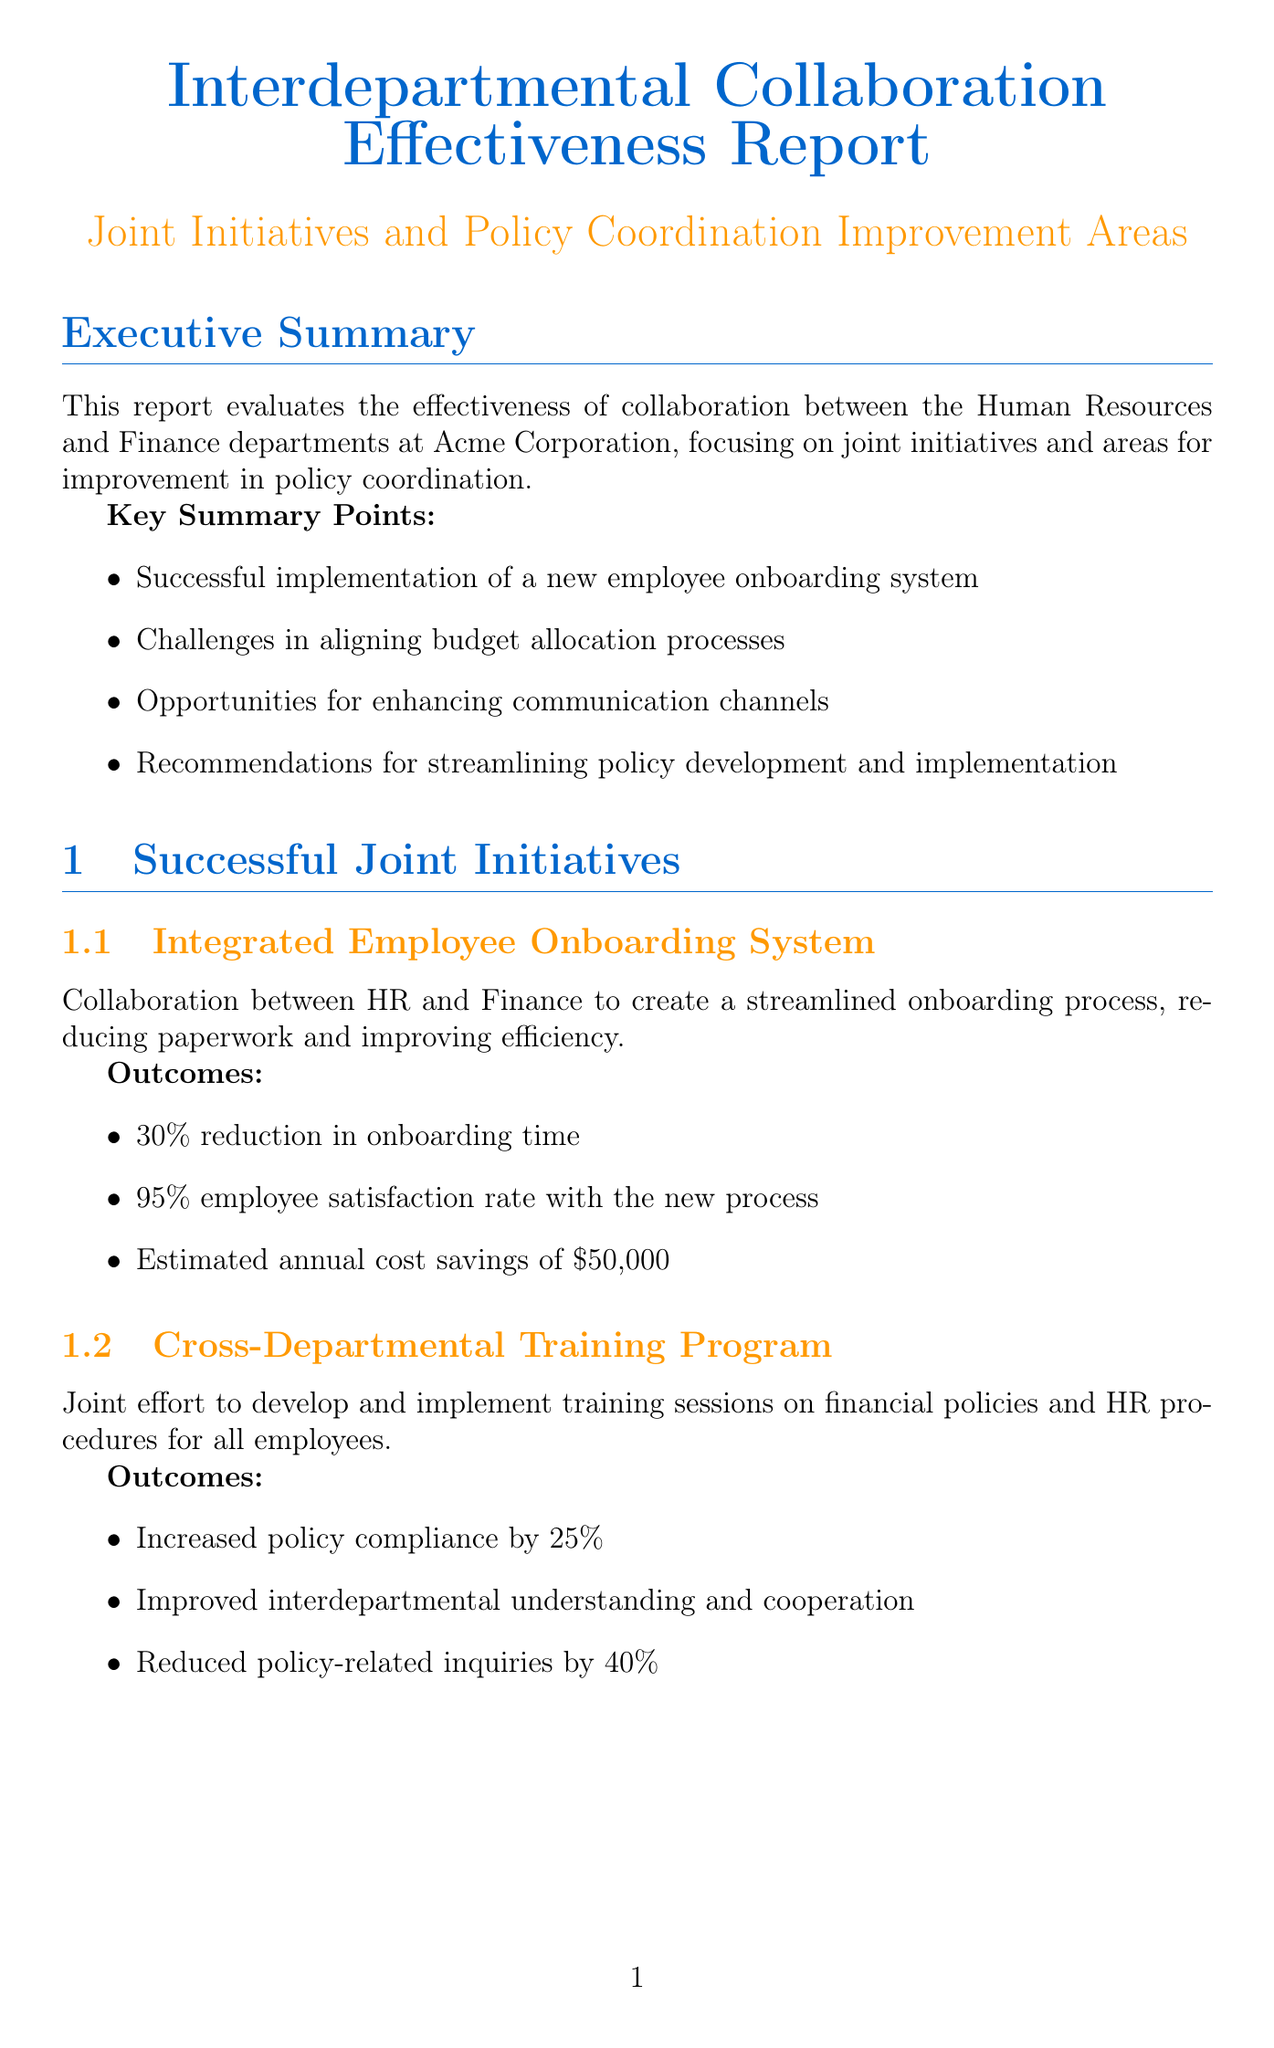What are the key departments evaluated in the report? The report evaluates the collaboration between the Human Resources and Finance departments.
Answer: Human Resources and Finance What is the percentage of improvement in policy compliance from the training program? The Cross-Departmental Training Program led to a 25% increase in policy compliance.
Answer: 25% What is the current value of the Joint Initiative Success Rate? The current value for the Joint Initiative Success Rate is 65%.
Answer: 65% What are the estimated annual cost savings from the Integrated Employee Onboarding System? The Integrated Employee Onboarding System results in estimated annual cost savings of $50,000.
Answer: $50,000 What is one recommended action for improving the budget allocation process? One recommended action is to establish quarterly joint budget review meetings.
Answer: Establish quarterly joint budget review meetings What is the proposed timeline for establishing the joint policy review committee? The priority action intends to establish the joint policy review committee within the next 30 days.
Answer: Within the next 30 days What is the target value for Policy Implementation Time? The target value for Policy Implementation Time is 30 days.
Answer: 30 days What percentage of action items are successfully completed after joint meetings? Currently, 70% of action items are successfully completed following joint meetings.
Answer: 70% What platform is proposed for real-time interdepartmental communication? The proposed platform for real-time interdepartmental communication is Slack.
Answer: Slack 